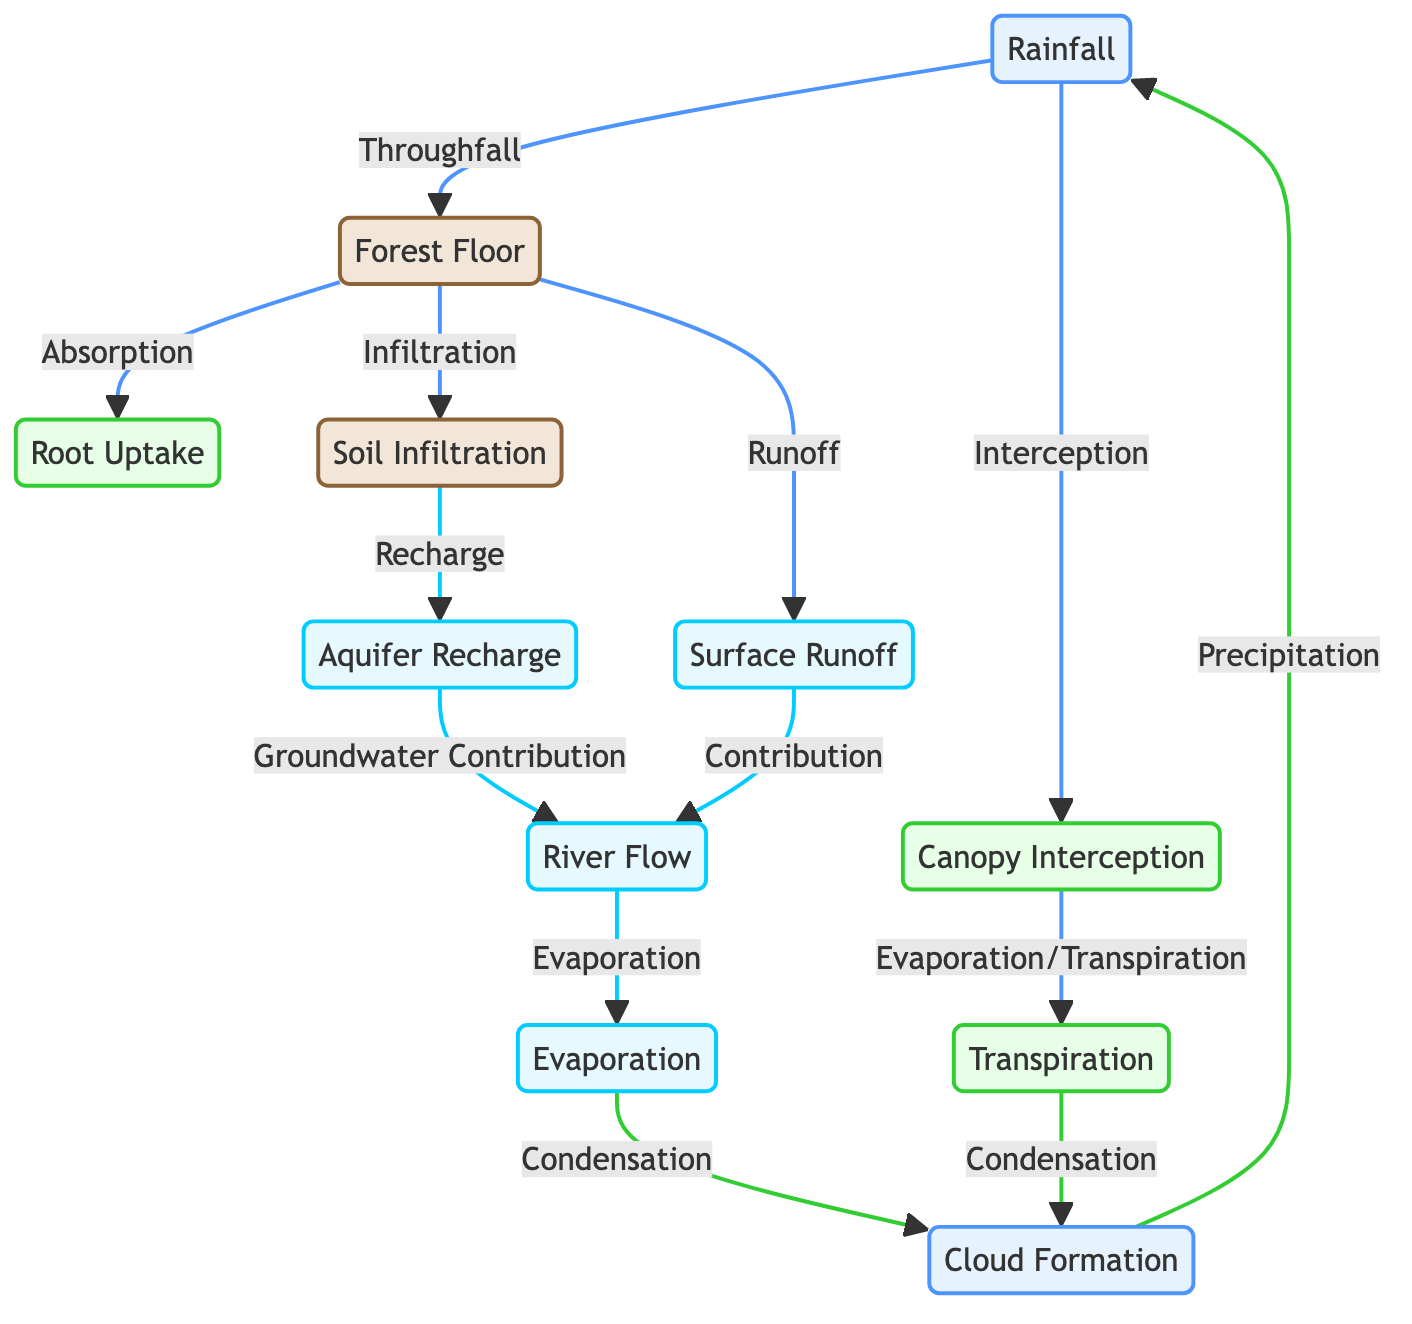What is the first process in the hydrological cycle according to the diagram? The diagram starts with "Rainfall," indicating that it is the first process in the hydrological cycle.
Answer: Rainfall How many different nodes are present in the diagram? By counting all distinct nodes represented in the diagram, there are a total of 11 nodes, which include processes and states of water.
Answer: 11 Which node represents the process of water returning to the atmosphere? The node labeled "Evaporation" indicates the process where water returns to the atmosphere.
Answer: Evaporation What process follows "Soil Infiltration"? From the diagram, "Soil Infiltration" leads to "Aquifer Recharge," suggesting that the water eventually recharges the groundwater.
Answer: Aquifer Recharge Which two nodes lead to "Cloud Formation"? The diagram shows that both "Evaporation" and "Transpiration" contribute to "Cloud Formation," indicating various sources of atmospheric moisture.
Answer: Evaporation and Transpiration How does water from the "Forest Floor" contribute to rivers? Water from the "Forest Floor" can contribute to rivers through the processes of "Surface Runoff" and "Aquifer Recharge," which emphasize direct runoff or groundwater strategies.
Answer: Surface Runoff and Aquifer Recharge What is the last process in the cycle before returning to "Rainfall"? The cycle returns to "Rainfall" after "Cloud Formation" releases precipitation, making it the last process before the cycle begins again.
Answer: Cloud Formation Which processes involve tree contributions? The processes "Canopy Interception," "Root Uptake," "Transpiration," and "Surface Runoff" involve trees contributing to the water cycle dynamics.
Answer: Canopy Interception, Root Uptake, Transpiration, Surface Runoff How is "River Flow" influenced according to the diagram? "River Flow" is influenced by both "Aquifer Recharge" and "Surface Runoff," illustrating the relationship between surface and groundwater contributions to rivers.
Answer: Aquifer Recharge and Surface Runoff 